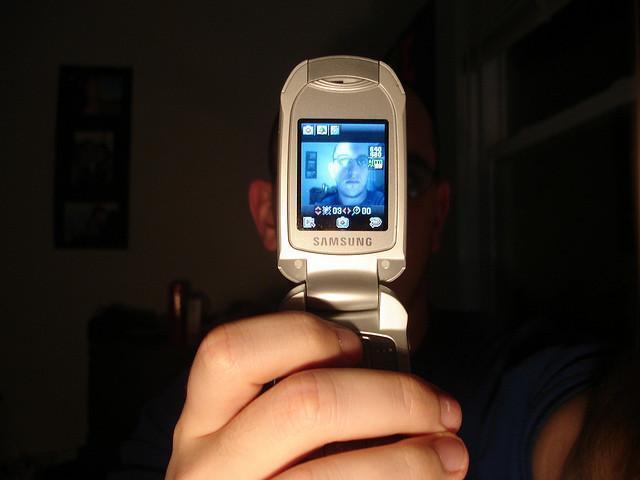How many people can you see?
Give a very brief answer. 2. How many yellow boats are there?
Give a very brief answer. 0. 